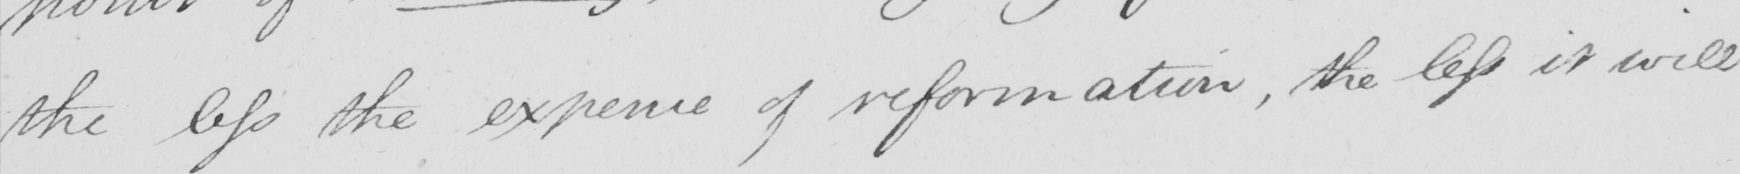Can you tell me what this handwritten text says? the less the expence of reformation , the less it will 